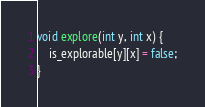<code> <loc_0><loc_0><loc_500><loc_500><_C++_>void explore(int y, int x) {
    is_explorable[y][x] = false;
}</code> 